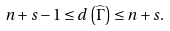Convert formula to latex. <formula><loc_0><loc_0><loc_500><loc_500>n + s - 1 \leq d \left ( \widehat { \Gamma } \right ) \leq n + s .</formula> 